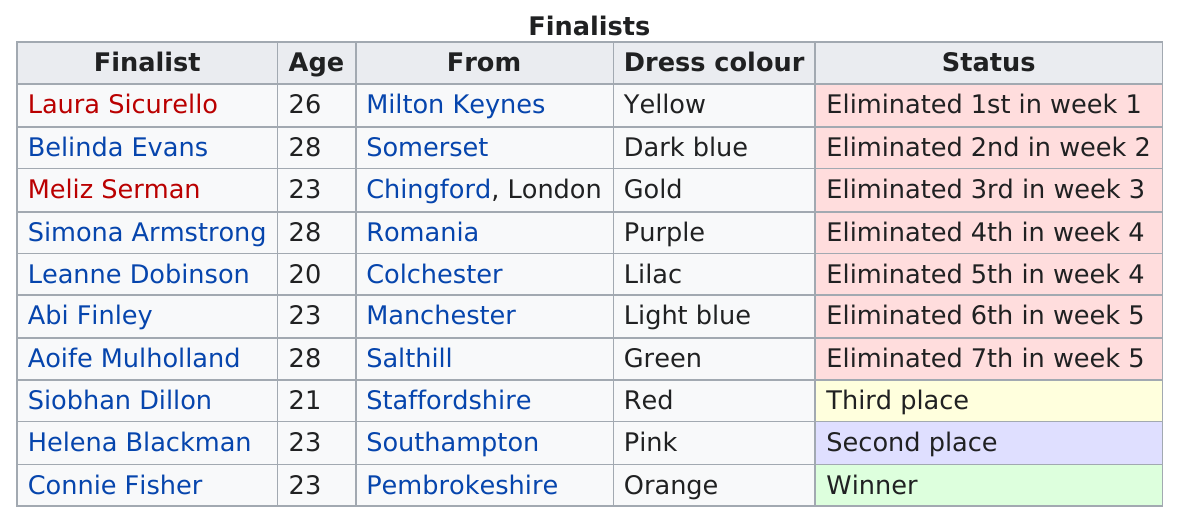Highlight a few significant elements in this photo. There are four finalists who are 23 years old. Simona Armstrong, who is from outside of Great Britain, has been identified as a suspect in the case. Laura Sicurello is the finalist who came in last. A total of 10 finalists were present. The number of finalists who were 23 years old is four. 